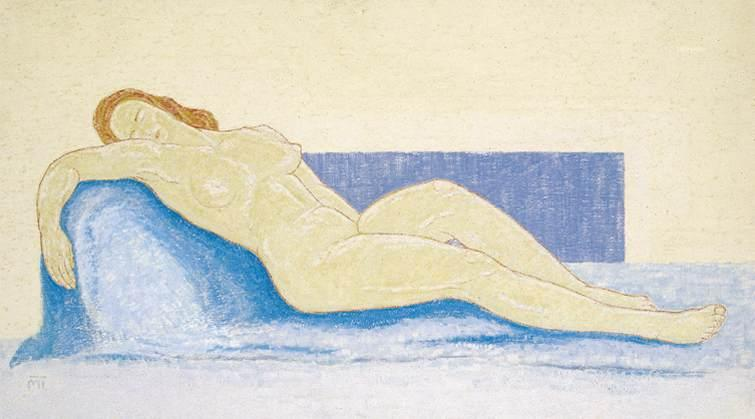What artistic techniques are evident in this drawing? The image demonstrates several key artistic techniques. The use of pastels allows for smooth, blended transitions between colors, creating a soft and gentle appearance. The impressionistic style is evident in the way the artist captures light and movement with loose, expressive brush strokes. The background is kept relatively plain to keep the focus on the subject. Additionally, there is a strong emphasis on the human form, with careful attention paid to the curvature and posture of the reclining woman, showcasing the artist's skill in anatomical illustration. The overall composition balances color and form to evoke a sense of calm and relaxation. Can you explain how the composition affects the viewer's perception of the image? The composition plays a crucial role in shaping the viewer's perception of the image. By positioning the reclining woman centrally against the contrasting yellow background and blue couch, the artist draws immediate attention to the subject. The horizontal orientation of the body, paired with the soft curves and relaxed posture, conveys a sense of ease and tranquility. The clear separation of the background, couch, and subject creates distinct layers that add depth to the scene. The use of light and shadow subtly guides the viewer's eye along the contours of the form, enhancing the perception of movement and fluidity. Overall, the composition's balance and harmony contribute to a peaceful and contemplative viewing experience. 